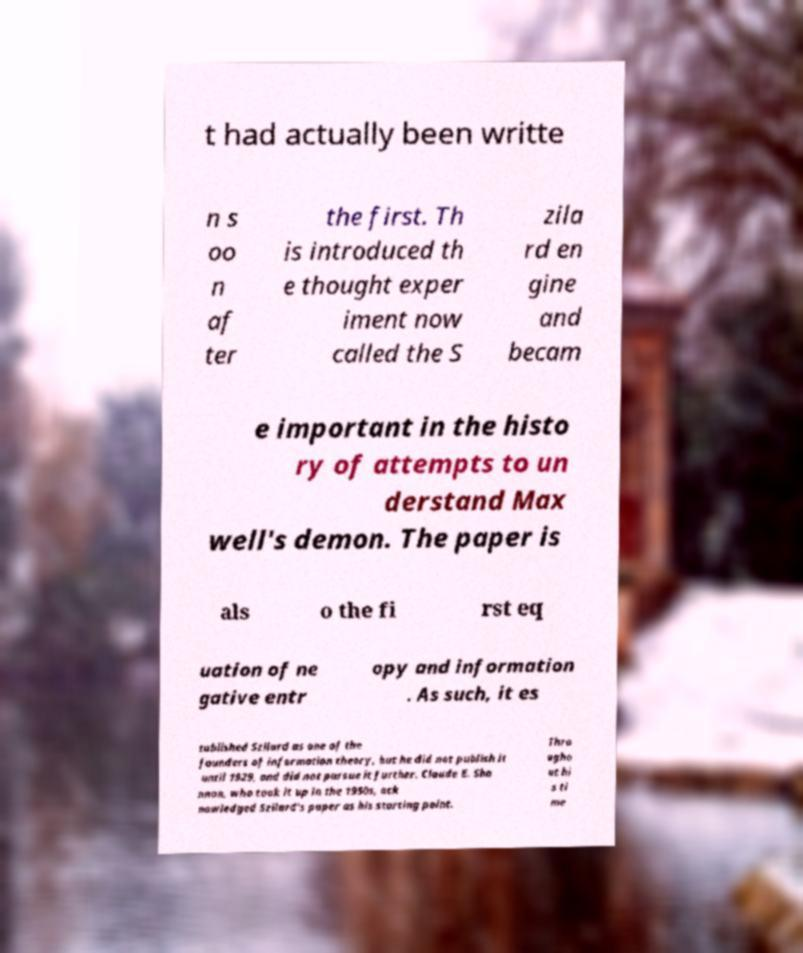Could you extract and type out the text from this image? t had actually been writte n s oo n af ter the first. Th is introduced th e thought exper iment now called the S zila rd en gine and becam e important in the histo ry of attempts to un derstand Max well's demon. The paper is als o the fi rst eq uation of ne gative entr opy and information . As such, it es tablished Szilard as one of the founders of information theory, but he did not publish it until 1929, and did not pursue it further. Claude E. Sha nnon, who took it up in the 1950s, ack nowledged Szilard's paper as his starting point. Thro ugho ut hi s ti me 